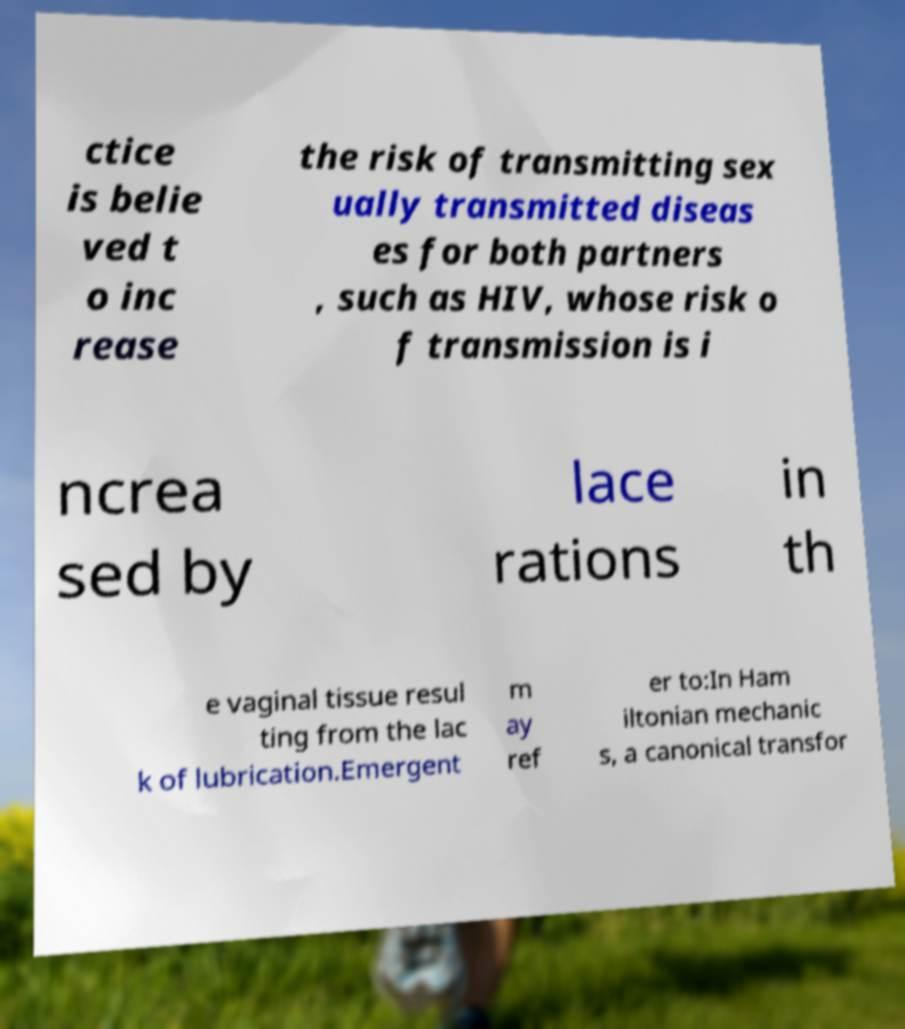Please identify and transcribe the text found in this image. ctice is belie ved t o inc rease the risk of transmitting sex ually transmitted diseas es for both partners , such as HIV, whose risk o f transmission is i ncrea sed by lace rations in th e vaginal tissue resul ting from the lac k of lubrication.Emergent m ay ref er to:In Ham iltonian mechanic s, a canonical transfor 